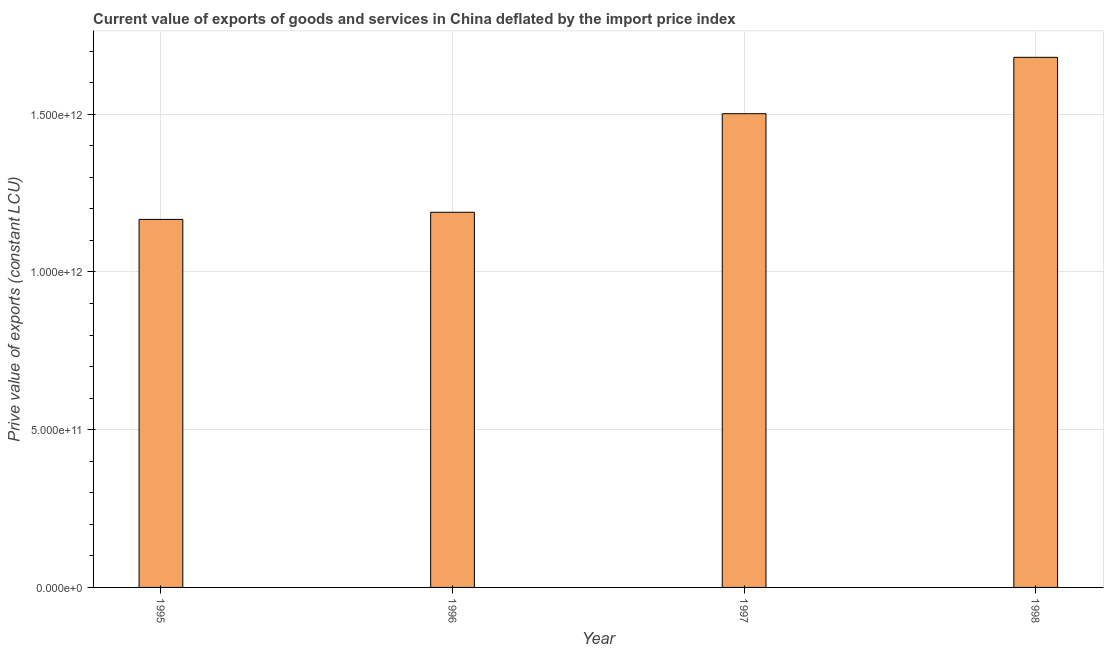Does the graph contain any zero values?
Ensure brevity in your answer.  No. Does the graph contain grids?
Your answer should be compact. Yes. What is the title of the graph?
Make the answer very short. Current value of exports of goods and services in China deflated by the import price index. What is the label or title of the X-axis?
Offer a terse response. Year. What is the label or title of the Y-axis?
Provide a succinct answer. Prive value of exports (constant LCU). What is the price value of exports in 1996?
Keep it short and to the point. 1.19e+12. Across all years, what is the maximum price value of exports?
Your answer should be compact. 1.68e+12. Across all years, what is the minimum price value of exports?
Provide a succinct answer. 1.17e+12. What is the sum of the price value of exports?
Offer a terse response. 5.54e+12. What is the difference between the price value of exports in 1995 and 1998?
Your answer should be very brief. -5.14e+11. What is the average price value of exports per year?
Provide a short and direct response. 1.38e+12. What is the median price value of exports?
Provide a succinct answer. 1.35e+12. In how many years, is the price value of exports greater than 1100000000000 LCU?
Make the answer very short. 4. What is the ratio of the price value of exports in 1995 to that in 1997?
Your answer should be compact. 0.78. Is the price value of exports in 1995 less than that in 1996?
Give a very brief answer. Yes. What is the difference between the highest and the second highest price value of exports?
Give a very brief answer. 1.79e+11. What is the difference between the highest and the lowest price value of exports?
Make the answer very short. 5.14e+11. In how many years, is the price value of exports greater than the average price value of exports taken over all years?
Offer a terse response. 2. How many years are there in the graph?
Give a very brief answer. 4. What is the difference between two consecutive major ticks on the Y-axis?
Your response must be concise. 5.00e+11. What is the Prive value of exports (constant LCU) of 1995?
Offer a very short reply. 1.17e+12. What is the Prive value of exports (constant LCU) in 1996?
Keep it short and to the point. 1.19e+12. What is the Prive value of exports (constant LCU) in 1997?
Provide a succinct answer. 1.50e+12. What is the Prive value of exports (constant LCU) in 1998?
Make the answer very short. 1.68e+12. What is the difference between the Prive value of exports (constant LCU) in 1995 and 1996?
Offer a very short reply. -2.26e+1. What is the difference between the Prive value of exports (constant LCU) in 1995 and 1997?
Provide a short and direct response. -3.35e+11. What is the difference between the Prive value of exports (constant LCU) in 1995 and 1998?
Ensure brevity in your answer.  -5.14e+11. What is the difference between the Prive value of exports (constant LCU) in 1996 and 1997?
Keep it short and to the point. -3.12e+11. What is the difference between the Prive value of exports (constant LCU) in 1996 and 1998?
Make the answer very short. -4.91e+11. What is the difference between the Prive value of exports (constant LCU) in 1997 and 1998?
Ensure brevity in your answer.  -1.79e+11. What is the ratio of the Prive value of exports (constant LCU) in 1995 to that in 1996?
Provide a short and direct response. 0.98. What is the ratio of the Prive value of exports (constant LCU) in 1995 to that in 1997?
Keep it short and to the point. 0.78. What is the ratio of the Prive value of exports (constant LCU) in 1995 to that in 1998?
Offer a terse response. 0.69. What is the ratio of the Prive value of exports (constant LCU) in 1996 to that in 1997?
Provide a succinct answer. 0.79. What is the ratio of the Prive value of exports (constant LCU) in 1996 to that in 1998?
Keep it short and to the point. 0.71. What is the ratio of the Prive value of exports (constant LCU) in 1997 to that in 1998?
Your answer should be very brief. 0.89. 